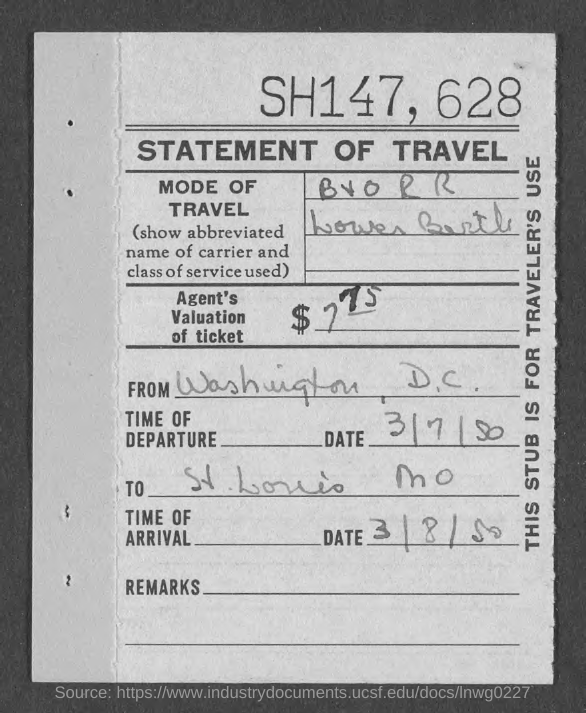List a handful of essential elements in this visual. The destination is St. Louis, Missouri. The date of arrival is March 8, 1950. The document is titled 'STATEMENT OF TRAVEL'. The date of departure is March 7th, 1950. This stub is intended for the use of travelers. 